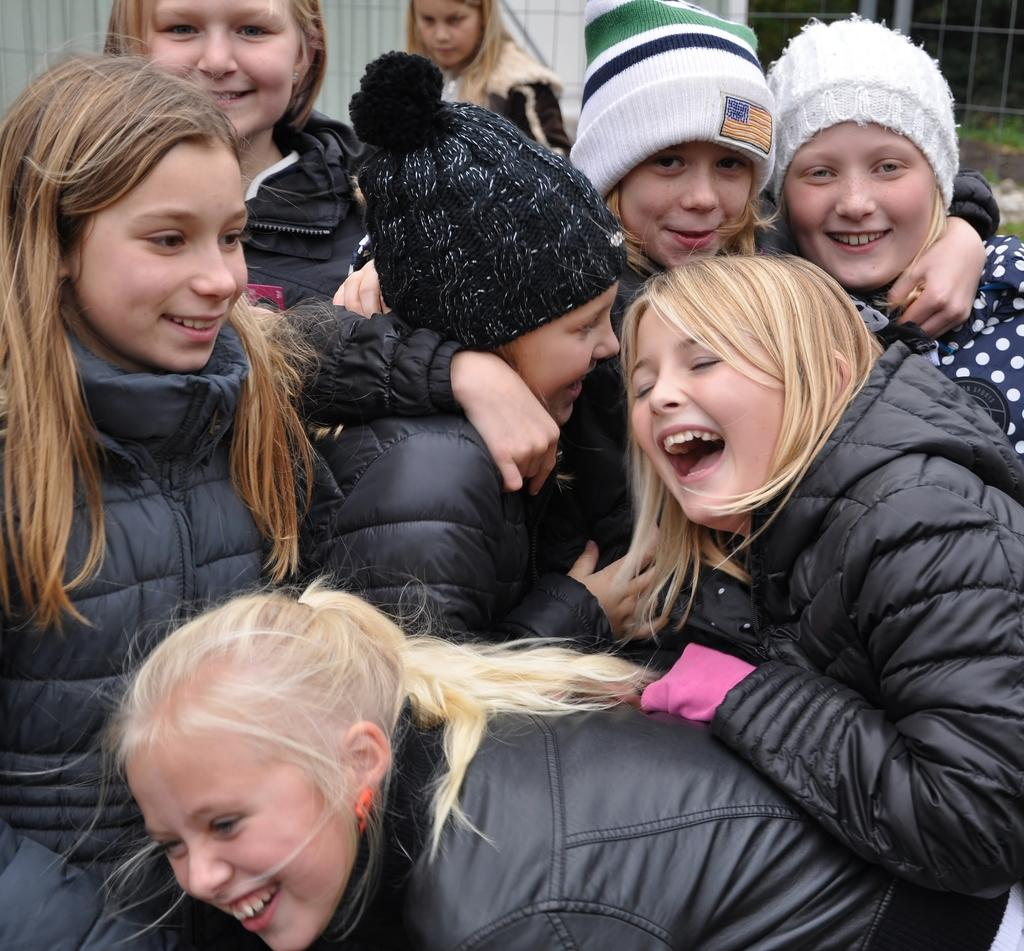What is the main subject of the image? The main subject of the image is a group of children. How are the children dressed? The children are wearing different color dresses. What are the children doing in the image? The children are gathered together and smiling. Can you describe the person in the background of the image? There is a person standing in the background of the image, but no specific details about them are provided. What else can be seen in the background of the image? There are other objects in the background of the image, but no specific details are given. What type of horn is being played by the children in the image? There is no horn present in the image; the children are simply smiling and gathered together. 